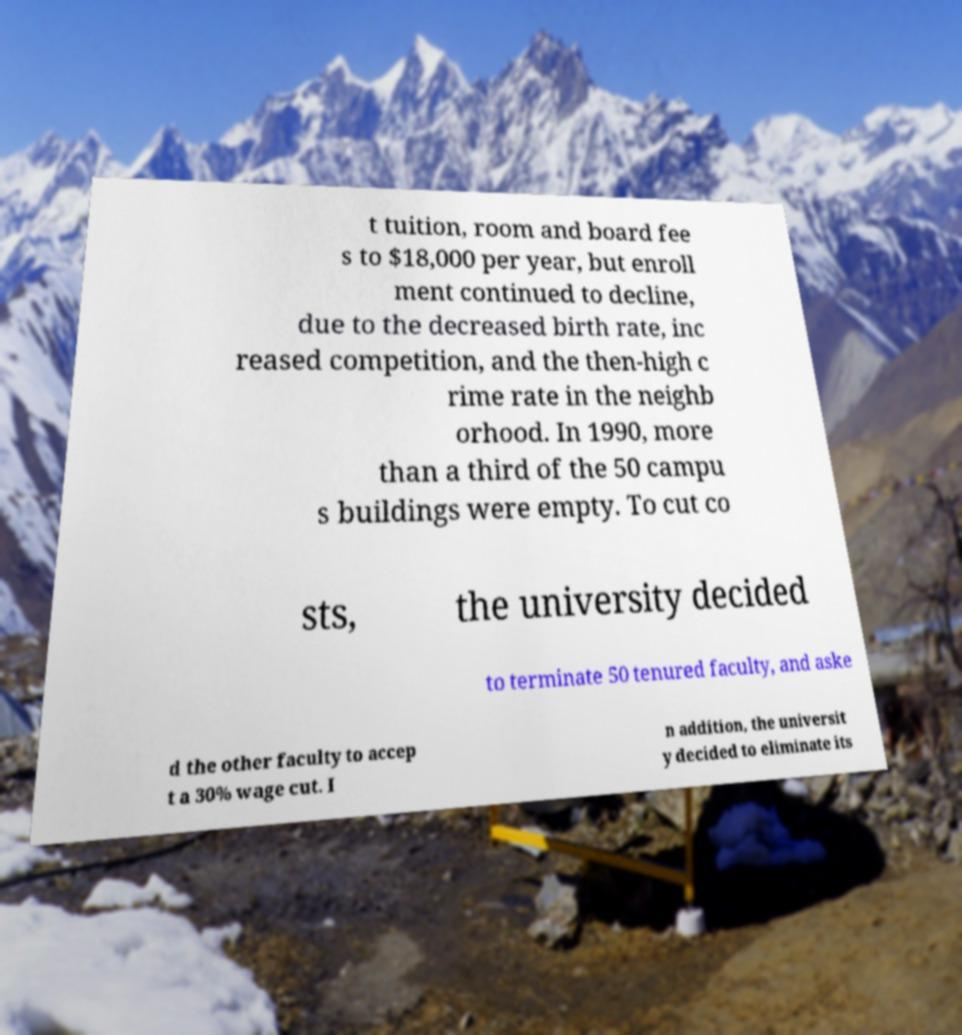For documentation purposes, I need the text within this image transcribed. Could you provide that? t tuition, room and board fee s to $18,000 per year, but enroll ment continued to decline, due to the decreased birth rate, inc reased competition, and the then-high c rime rate in the neighb orhood. In 1990, more than a third of the 50 campu s buildings were empty. To cut co sts, the university decided to terminate 50 tenured faculty, and aske d the other faculty to accep t a 30% wage cut. I n addition, the universit y decided to eliminate its 